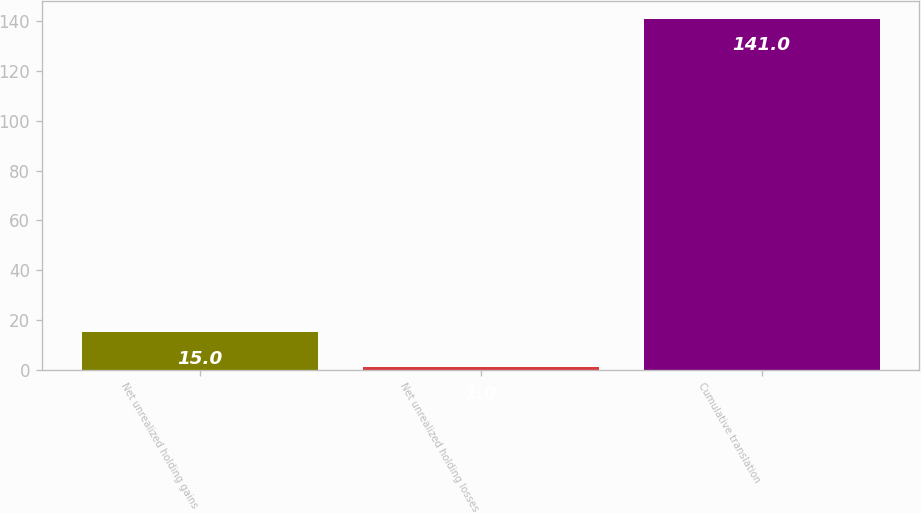Convert chart. <chart><loc_0><loc_0><loc_500><loc_500><bar_chart><fcel>Net unrealized holding gains<fcel>Net unrealized holding losses<fcel>Cumulative translation<nl><fcel>15<fcel>1<fcel>141<nl></chart> 